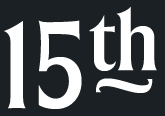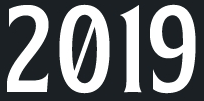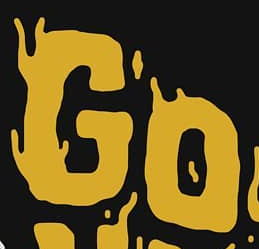What words are shown in these images in order, separated by a semicolon? 15th; 2019; GO 